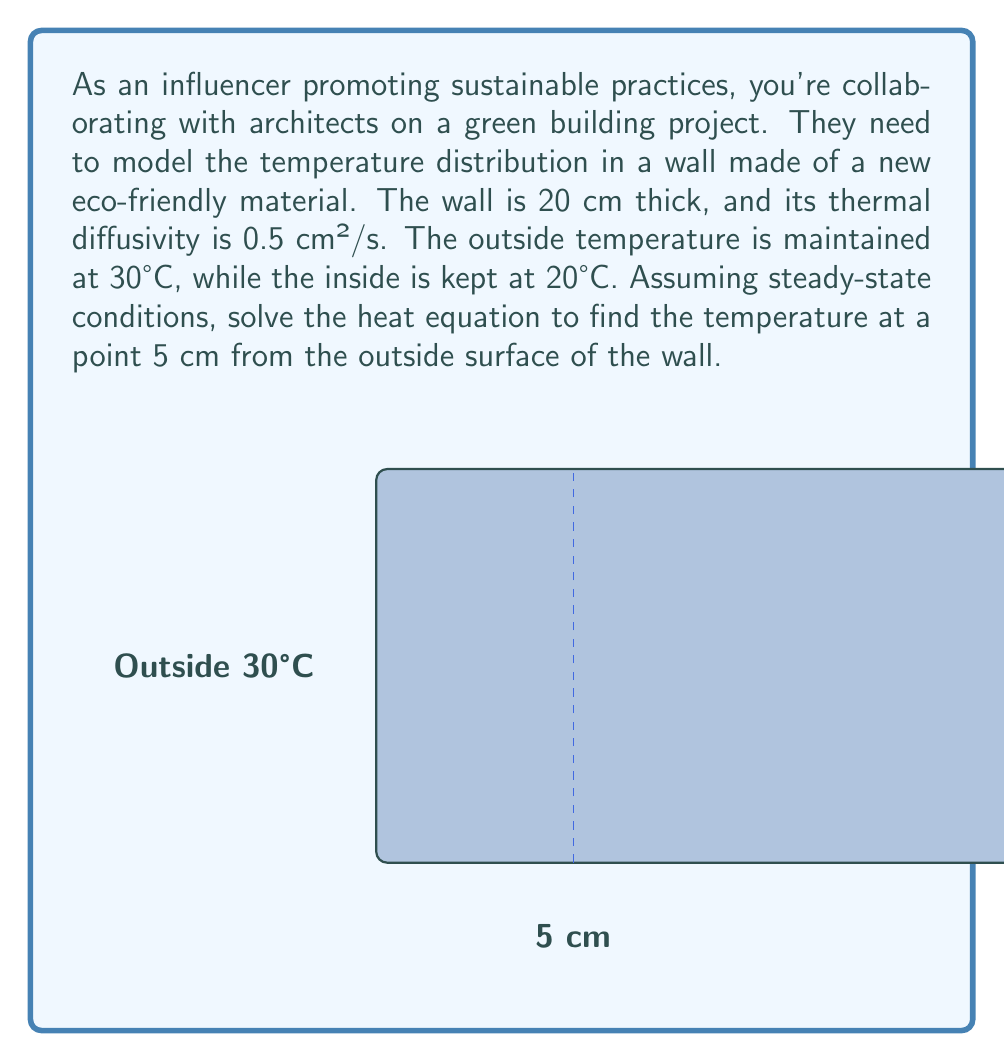Can you answer this question? Let's solve this problem step-by-step using the heat equation:

1) The steady-state heat equation in one dimension is:

   $$\frac{d^2T}{dx^2} = 0$$

2) The general solution to this equation is:

   $$T(x) = Ax + B$$

   where A and B are constants we need to determine.

3) We have the following boundary conditions:
   At x = 0, T = 30°C
   At x = 20 cm, T = 20°C

4) Applying these conditions:
   At x = 0: 30 = B
   At x = 20: 20 = 20A + B

5) Substituting B = 30 into the second equation:
   20 = 20A + 30
   -10 = 20A
   A = -0.5

6) Therefore, our solution is:

   $$T(x) = -0.5x + 30$$

7) To find the temperature at 5 cm from the outside:

   $$T(5) = -0.5(5) + 30 = 27.5°C$$

Note: The thermal diffusivity given in the problem (0.5 cm²/s) is not needed for solving the steady-state heat equation, but it would be crucial for time-dependent problems.
Answer: 27.5°C 